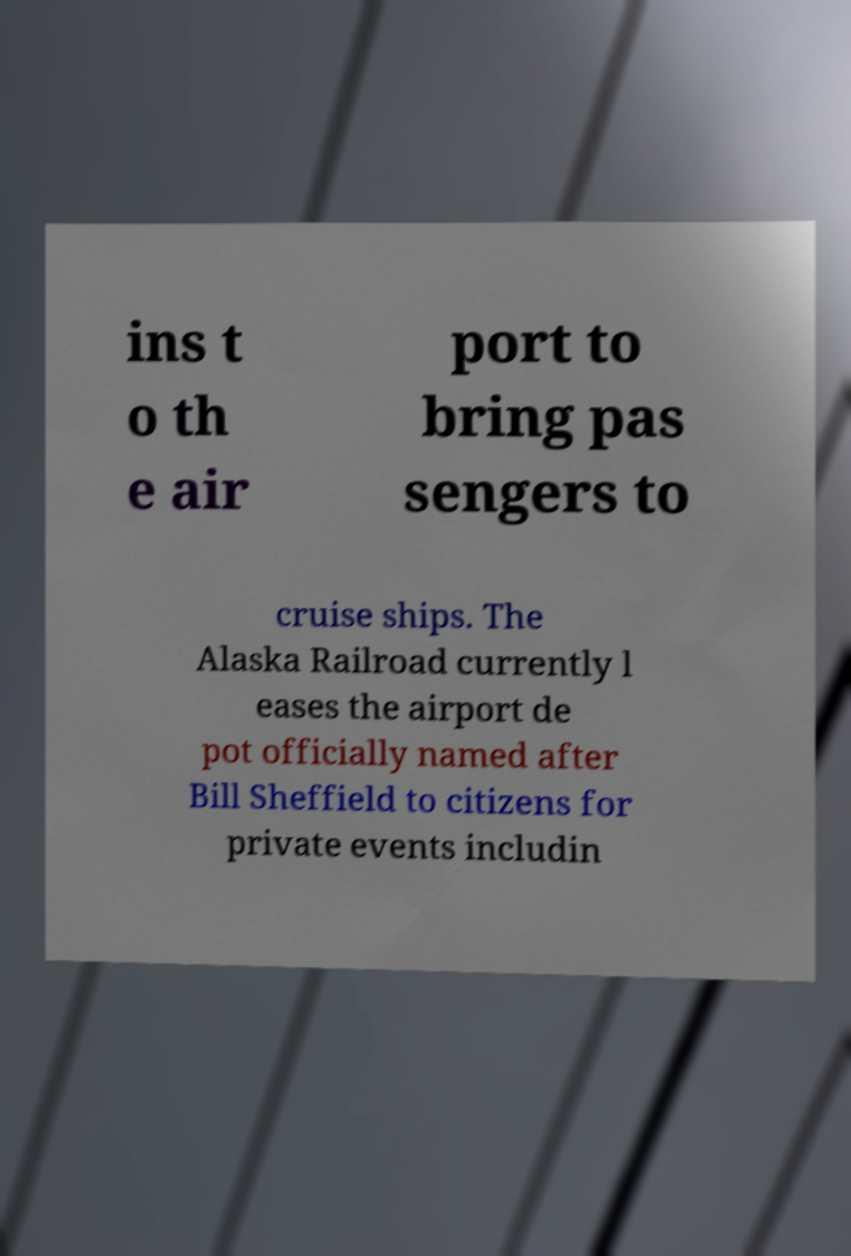What messages or text are displayed in this image? I need them in a readable, typed format. ins t o th e air port to bring pas sengers to cruise ships. The Alaska Railroad currently l eases the airport de pot officially named after Bill Sheffield to citizens for private events includin 